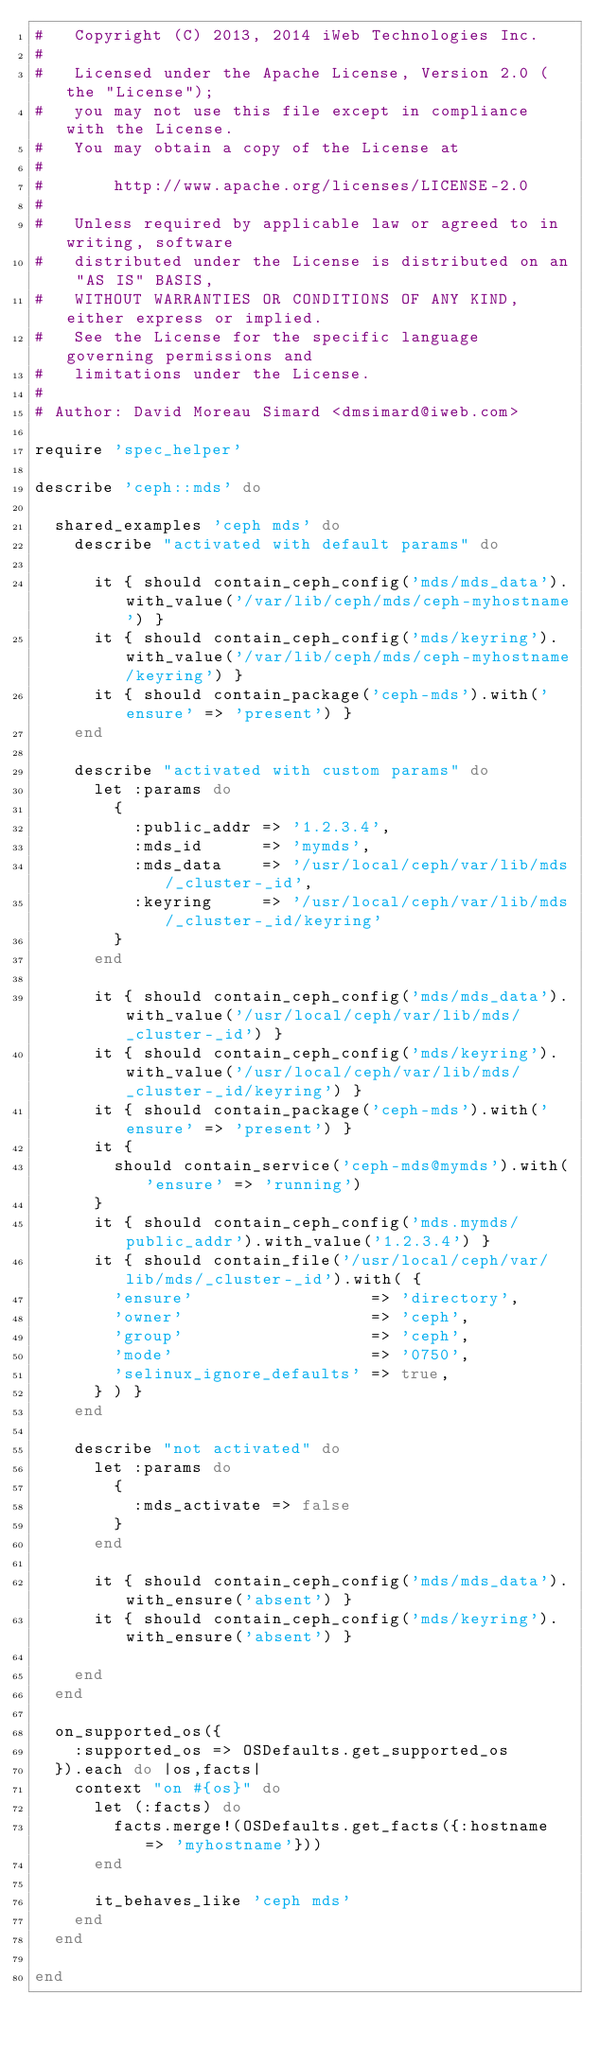<code> <loc_0><loc_0><loc_500><loc_500><_Ruby_>#   Copyright (C) 2013, 2014 iWeb Technologies Inc.
#
#   Licensed under the Apache License, Version 2.0 (the "License");
#   you may not use this file except in compliance with the License.
#   You may obtain a copy of the License at
#
#       http://www.apache.org/licenses/LICENSE-2.0
#
#   Unless required by applicable law or agreed to in writing, software
#   distributed under the License is distributed on an "AS IS" BASIS,
#   WITHOUT WARRANTIES OR CONDITIONS OF ANY KIND, either express or implied.
#   See the License for the specific language governing permissions and
#   limitations under the License.
#
# Author: David Moreau Simard <dmsimard@iweb.com>

require 'spec_helper'

describe 'ceph::mds' do

  shared_examples 'ceph mds' do
    describe "activated with default params" do

      it { should contain_ceph_config('mds/mds_data').with_value('/var/lib/ceph/mds/ceph-myhostname') }
      it { should contain_ceph_config('mds/keyring').with_value('/var/lib/ceph/mds/ceph-myhostname/keyring') }
      it { should contain_package('ceph-mds').with('ensure' => 'present') }
    end

    describe "activated with custom params" do
      let :params do
        {
          :public_addr => '1.2.3.4',
          :mds_id      => 'mymds',
          :mds_data    => '/usr/local/ceph/var/lib/mds/_cluster-_id',
          :keyring     => '/usr/local/ceph/var/lib/mds/_cluster-_id/keyring'
        }
      end

      it { should contain_ceph_config('mds/mds_data').with_value('/usr/local/ceph/var/lib/mds/_cluster-_id') }
      it { should contain_ceph_config('mds/keyring').with_value('/usr/local/ceph/var/lib/mds/_cluster-_id/keyring') }
      it { should contain_package('ceph-mds').with('ensure' => 'present') }
      it {
        should contain_service('ceph-mds@mymds').with('ensure' => 'running')
      }
      it { should contain_ceph_config('mds.mymds/public_addr').with_value('1.2.3.4') }
      it { should contain_file('/usr/local/ceph/var/lib/mds/_cluster-_id').with( {
        'ensure'                  => 'directory',
        'owner'                   => 'ceph',
        'group'                   => 'ceph',
        'mode'                    => '0750',
        'selinux_ignore_defaults' => true,
      } ) }
    end

    describe "not activated" do
      let :params do
        {
          :mds_activate => false
        }
      end

      it { should contain_ceph_config('mds/mds_data').with_ensure('absent') }
      it { should contain_ceph_config('mds/keyring').with_ensure('absent') }

    end
  end

  on_supported_os({
    :supported_os => OSDefaults.get_supported_os
  }).each do |os,facts|
    context "on #{os}" do
      let (:facts) do
        facts.merge!(OSDefaults.get_facts({:hostname => 'myhostname'}))
      end

      it_behaves_like 'ceph mds'
    end
  end

end
</code> 